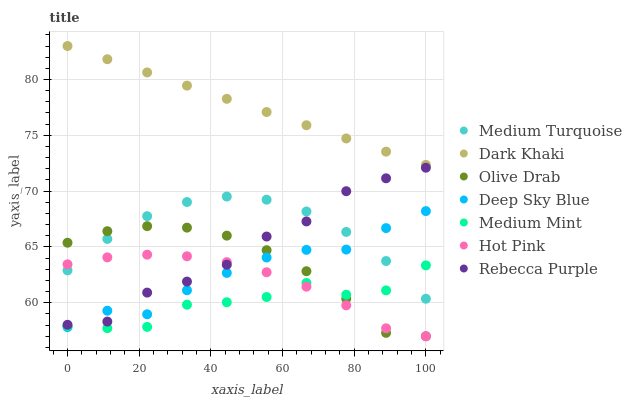Does Medium Mint have the minimum area under the curve?
Answer yes or no. Yes. Does Dark Khaki have the maximum area under the curve?
Answer yes or no. Yes. Does Medium Turquoise have the minimum area under the curve?
Answer yes or no. No. Does Medium Turquoise have the maximum area under the curve?
Answer yes or no. No. Is Dark Khaki the smoothest?
Answer yes or no. Yes. Is Medium Mint the roughest?
Answer yes or no. Yes. Is Medium Turquoise the smoothest?
Answer yes or no. No. Is Medium Turquoise the roughest?
Answer yes or no. No. Does Hot Pink have the lowest value?
Answer yes or no. Yes. Does Medium Turquoise have the lowest value?
Answer yes or no. No. Does Dark Khaki have the highest value?
Answer yes or no. Yes. Does Medium Turquoise have the highest value?
Answer yes or no. No. Is Olive Drab less than Dark Khaki?
Answer yes or no. Yes. Is Dark Khaki greater than Olive Drab?
Answer yes or no. Yes. Does Hot Pink intersect Rebecca Purple?
Answer yes or no. Yes. Is Hot Pink less than Rebecca Purple?
Answer yes or no. No. Is Hot Pink greater than Rebecca Purple?
Answer yes or no. No. Does Olive Drab intersect Dark Khaki?
Answer yes or no. No. 